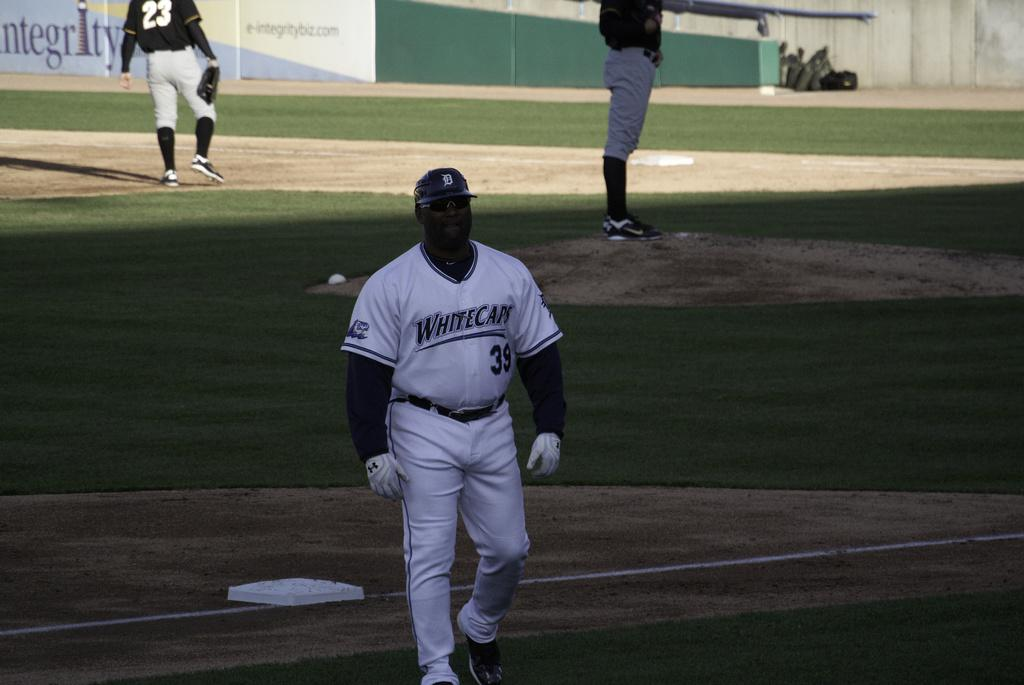<image>
Describe the image concisely. Player number 39 on the Whitecaps is walking away from the field. 